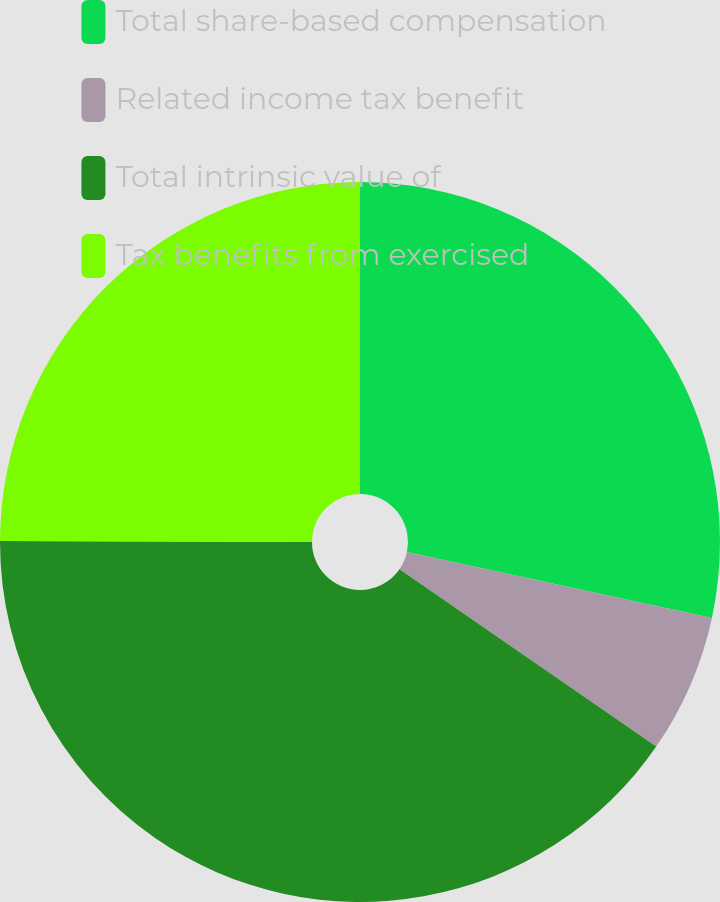Convert chart. <chart><loc_0><loc_0><loc_500><loc_500><pie_chart><fcel>Total share-based compensation<fcel>Related income tax benefit<fcel>Total intrinsic value of<fcel>Tax benefits from exercised<nl><fcel>28.38%<fcel>6.24%<fcel>40.42%<fcel>24.96%<nl></chart> 